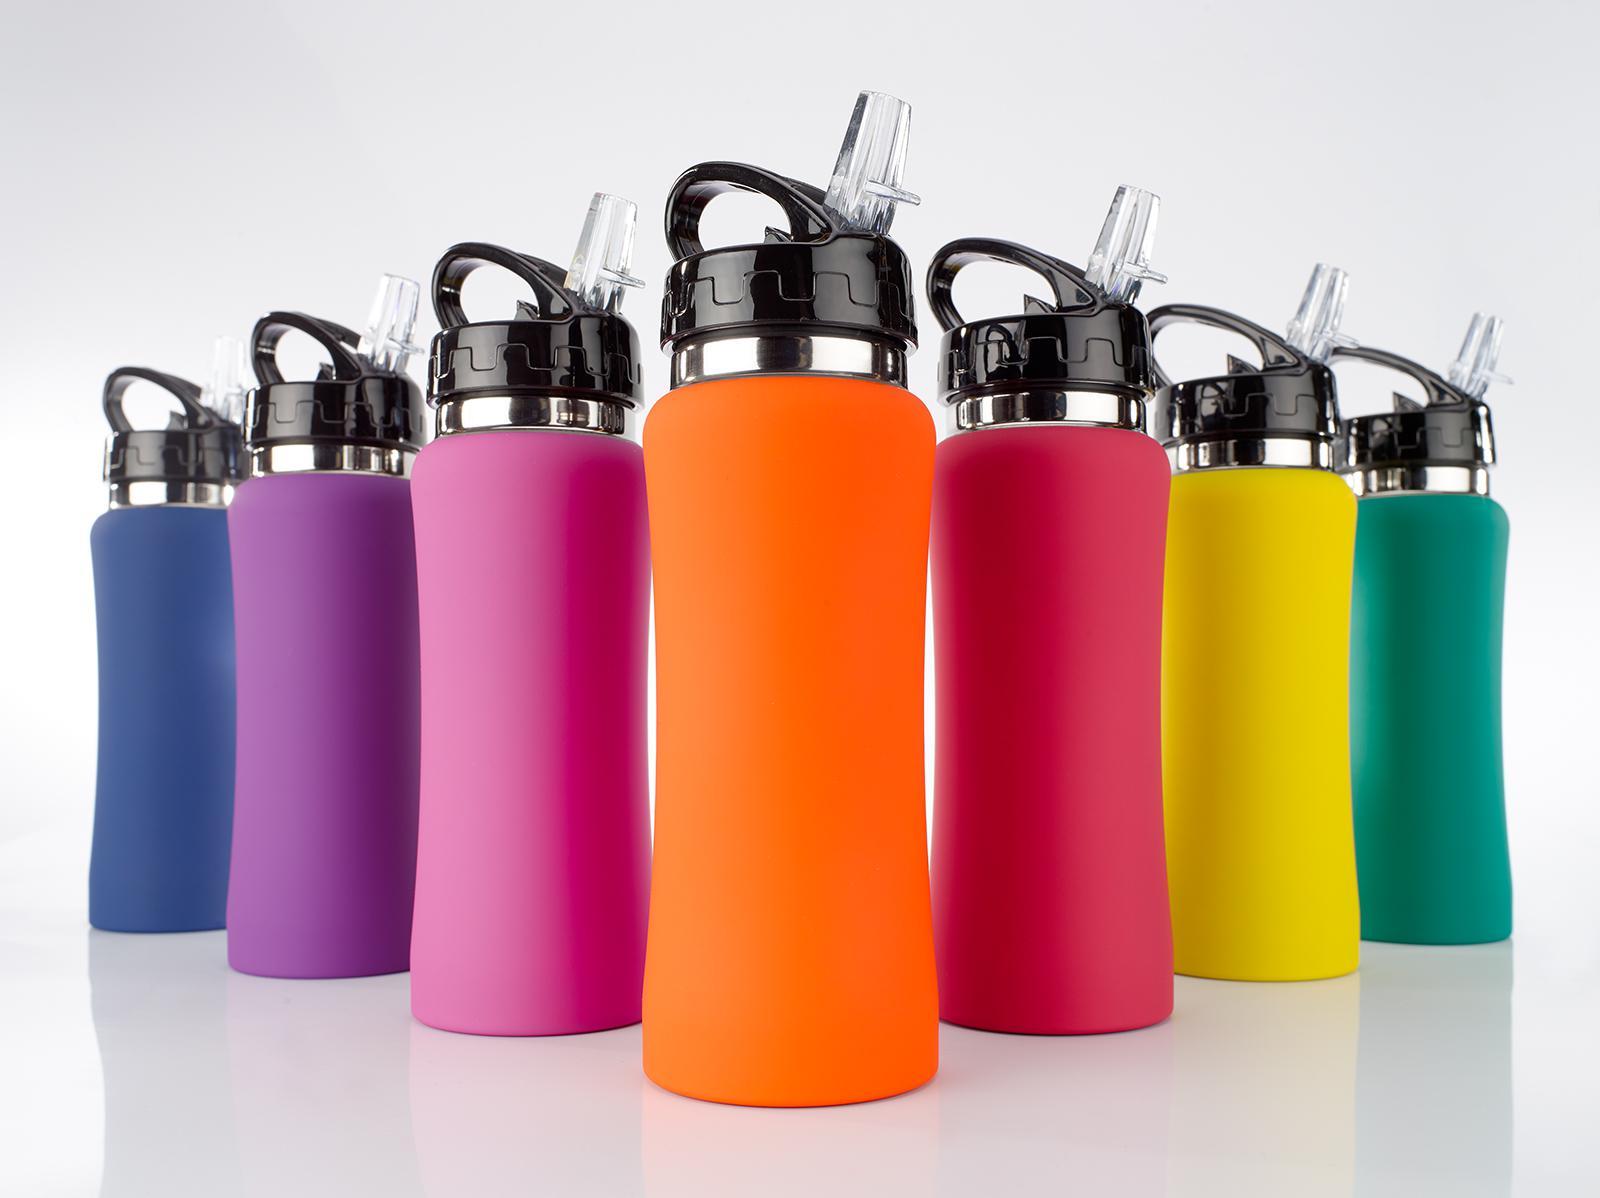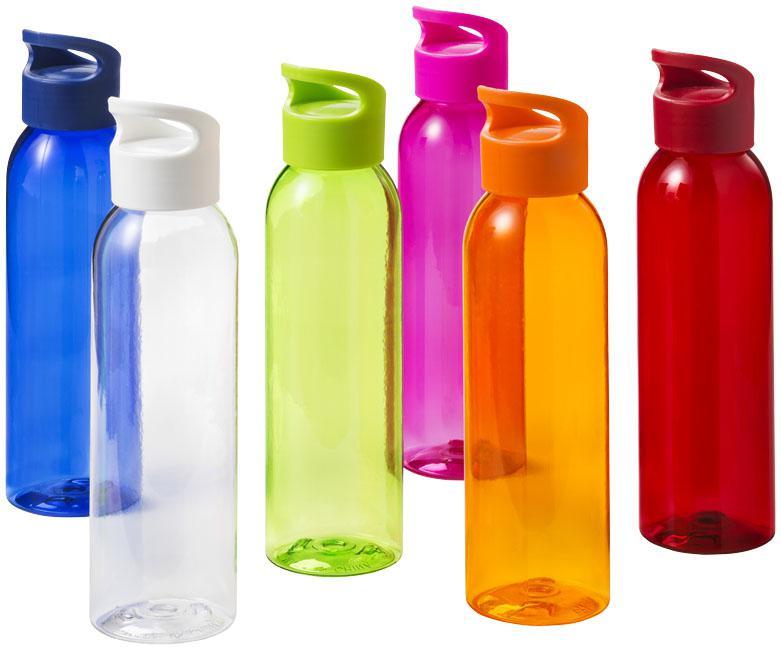The first image is the image on the left, the second image is the image on the right. Analyze the images presented: Is the assertion "There are two green bottles." valid? Answer yes or no. Yes. The first image is the image on the left, the second image is the image on the right. Analyze the images presented: Is the assertion "Each image contains multiple water bottles in different solid colors, and one image shows bottles arranged in a V-formation." valid? Answer yes or no. Yes. 